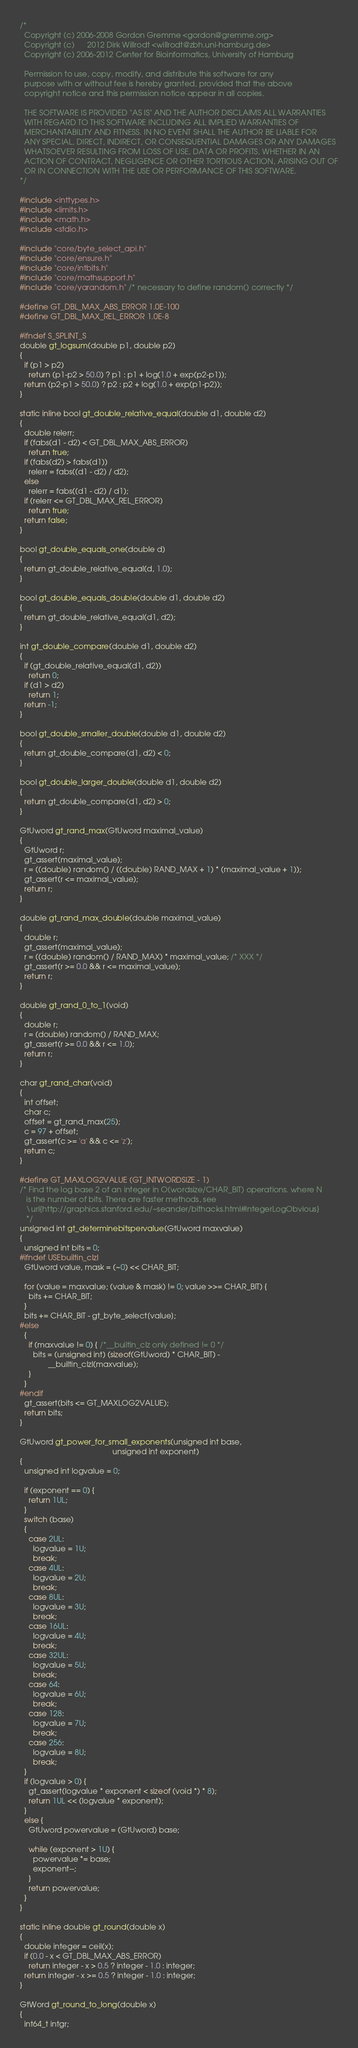Convert code to text. <code><loc_0><loc_0><loc_500><loc_500><_C_>/*
  Copyright (c) 2006-2008 Gordon Gremme <gordon@gremme.org>
  Copyright (c)      2012 Dirk Willrodt <willrodt@zbh.uni-hamburg.de>
  Copyright (c) 2006-2012 Center for Bioinformatics, University of Hamburg

  Permission to use, copy, modify, and distribute this software for any
  purpose with or without fee is hereby granted, provided that the above
  copyright notice and this permission notice appear in all copies.

  THE SOFTWARE IS PROVIDED "AS IS" AND THE AUTHOR DISCLAIMS ALL WARRANTIES
  WITH REGARD TO THIS SOFTWARE INCLUDING ALL IMPLIED WARRANTIES OF
  MERCHANTABILITY AND FITNESS. IN NO EVENT SHALL THE AUTHOR BE LIABLE FOR
  ANY SPECIAL, DIRECT, INDIRECT, OR CONSEQUENTIAL DAMAGES OR ANY DAMAGES
  WHATSOEVER RESULTING FROM LOSS OF USE, DATA OR PROFITS, WHETHER IN AN
  ACTION OF CONTRACT, NEGLIGENCE OR OTHER TORTIOUS ACTION, ARISING OUT OF
  OR IN CONNECTION WITH THE USE OR PERFORMANCE OF THIS SOFTWARE.
*/

#include <inttypes.h>
#include <limits.h>
#include <math.h>
#include <stdio.h>

#include "core/byte_select_api.h"
#include "core/ensure.h"
#include "core/intbits.h"
#include "core/mathsupport.h"
#include "core/yarandom.h" /* necessary to define random() correctly */

#define GT_DBL_MAX_ABS_ERROR 1.0E-100
#define GT_DBL_MAX_REL_ERROR 1.0E-8

#ifndef S_SPLINT_S
double gt_logsum(double p1, double p2)
{
  if (p1 > p2)
    return (p1-p2 > 50.0) ? p1 : p1 + log(1.0 + exp(p2-p1));
  return (p2-p1 > 50.0) ? p2 : p2 + log(1.0 + exp(p1-p2));
}

static inline bool gt_double_relative_equal(double d1, double d2)
{
  double relerr;
  if (fabs(d1 - d2) < GT_DBL_MAX_ABS_ERROR)
    return true;
  if (fabs(d2) > fabs(d1))
    relerr = fabs((d1 - d2) / d2);
  else
    relerr = fabs((d1 - d2) / d1);
  if (relerr <= GT_DBL_MAX_REL_ERROR)
    return true;
  return false;
}

bool gt_double_equals_one(double d)
{
  return gt_double_relative_equal(d, 1.0);
}

bool gt_double_equals_double(double d1, double d2)
{
  return gt_double_relative_equal(d1, d2);
}

int gt_double_compare(double d1, double d2)
{
  if (gt_double_relative_equal(d1, d2))
    return 0;
  if (d1 > d2)
    return 1;
  return -1;
}

bool gt_double_smaller_double(double d1, double d2)
{
  return gt_double_compare(d1, d2) < 0;
}

bool gt_double_larger_double(double d1, double d2)
{
  return gt_double_compare(d1, d2) > 0;
}

GtUword gt_rand_max(GtUword maximal_value)
{
  GtUword r;
  gt_assert(maximal_value);
  r = ((double) random() / ((double) RAND_MAX + 1) * (maximal_value + 1));
  gt_assert(r <= maximal_value);
  return r;
}

double gt_rand_max_double(double maximal_value)
{
  double r;
  gt_assert(maximal_value);
  r = ((double) random() / RAND_MAX) * maximal_value; /* XXX */
  gt_assert(r >= 0.0 && r <= maximal_value);
  return r;
}

double gt_rand_0_to_1(void)
{
  double r;
  r = (double) random() / RAND_MAX;
  gt_assert(r >= 0.0 && r <= 1.0);
  return r;
}

char gt_rand_char(void)
{
  int offset;
  char c;
  offset = gt_rand_max(25);
  c = 97 + offset;
  gt_assert(c >= 'a' && c <= 'z');
  return c;
}

#define GT_MAXLOG2VALUE (GT_INTWORDSIZE - 1)
/* Find the log base 2 of an integer in O(wordsize/CHAR_BIT) operations. where N
   is the number of bits. There are faster methods, see
   \url{http://graphics.stanford.edu/~seander/bithacks.html#IntegerLogObvious}
   */
unsigned int gt_determinebitspervalue(GtUword maxvalue)
{
  unsigned int bits = 0;
#ifndef USEbuiltin_clzl
  GtUword value, mask = (~0) << CHAR_BIT;

  for (value = maxvalue; (value & mask) != 0; value >>= CHAR_BIT) {
    bits += CHAR_BIT;
  }
  bits += CHAR_BIT - gt_byte_select[value];
#else
  {
    if (maxvalue != 0) { /*__builtin_clz only defined != 0 */
      bits = (unsigned int) (sizeof(GtUword) * CHAR_BIT) -
             __builtin_clzl(maxvalue);
    }
  }
#endif
  gt_assert(bits <= GT_MAXLOG2VALUE);
  return bits;
}

GtUword gt_power_for_small_exponents(unsigned int base,
                                           unsigned int exponent)
{
  unsigned int logvalue = 0;

  if (exponent == 0) {
    return 1UL;
  }
  switch (base)
  {
    case 2UL:
      logvalue = 1U;
      break;
    case 4UL:
      logvalue = 2U;
      break;
    case 8UL:
      logvalue = 3U;
      break;
    case 16UL:
      logvalue = 4U;
      break;
    case 32UL:
      logvalue = 5U;
      break;
    case 64:
      logvalue = 6U;
      break;
    case 128:
      logvalue = 7U;
      break;
    case 256:
      logvalue = 8U;
      break;
  }
  if (logvalue > 0) {
    gt_assert(logvalue * exponent < sizeof (void *) * 8);
    return 1UL << (logvalue * exponent);
  }
  else {
    GtUword powervalue = (GtUword) base;

    while (exponent > 1U) {
      powervalue *= base;
      exponent--;
    }
    return powervalue;
  }
}

static inline double gt_round(double x)
{
  double integer = ceil(x);
  if (0.0 - x < GT_DBL_MAX_ABS_ERROR)
    return integer - x > 0.5 ? integer - 1.0 : integer;
  return integer - x >= 0.5 ? integer - 1.0 : integer;
}

GtWord gt_round_to_long(double x)
{
  int64_t intgr;</code> 